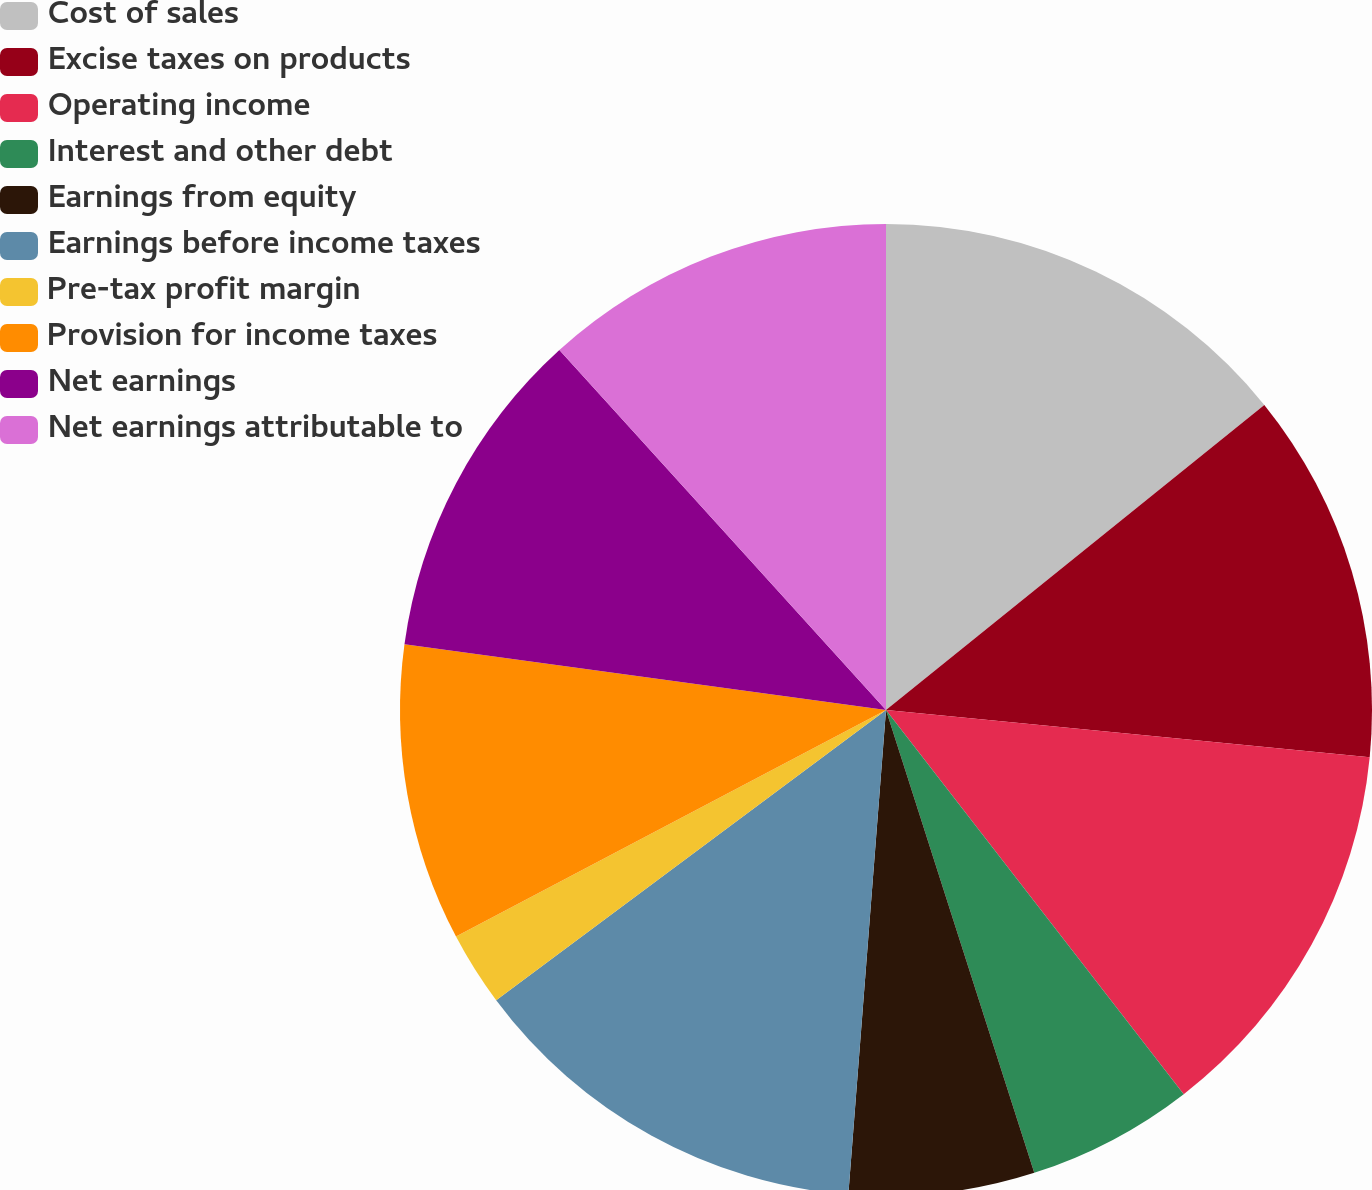Convert chart. <chart><loc_0><loc_0><loc_500><loc_500><pie_chart><fcel>Cost of sales<fcel>Excise taxes on products<fcel>Operating income<fcel>Interest and other debt<fcel>Earnings from equity<fcel>Earnings before income taxes<fcel>Pre-tax profit margin<fcel>Provision for income taxes<fcel>Net earnings<fcel>Net earnings attributable to<nl><fcel>14.2%<fcel>12.35%<fcel>12.96%<fcel>5.56%<fcel>6.17%<fcel>13.58%<fcel>2.47%<fcel>9.88%<fcel>11.11%<fcel>11.73%<nl></chart> 